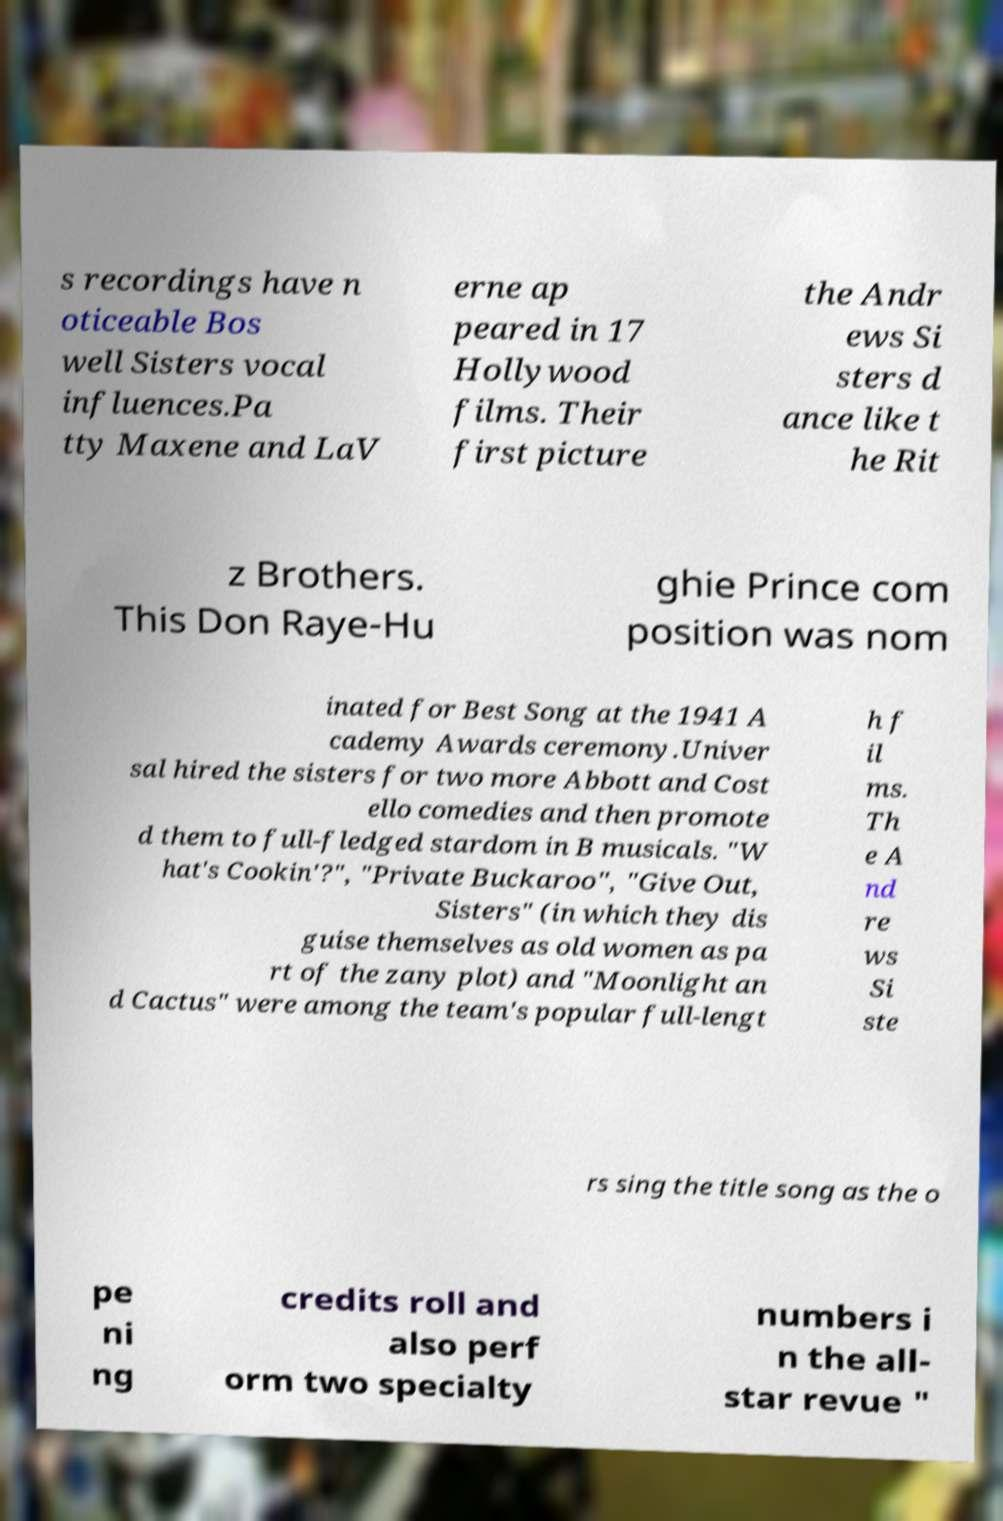Can you read and provide the text displayed in the image?This photo seems to have some interesting text. Can you extract and type it out for me? s recordings have n oticeable Bos well Sisters vocal influences.Pa tty Maxene and LaV erne ap peared in 17 Hollywood films. Their first picture the Andr ews Si sters d ance like t he Rit z Brothers. This Don Raye-Hu ghie Prince com position was nom inated for Best Song at the 1941 A cademy Awards ceremony.Univer sal hired the sisters for two more Abbott and Cost ello comedies and then promote d them to full-fledged stardom in B musicals. "W hat's Cookin'?", "Private Buckaroo", "Give Out, Sisters" (in which they dis guise themselves as old women as pa rt of the zany plot) and "Moonlight an d Cactus" were among the team's popular full-lengt h f il ms. Th e A nd re ws Si ste rs sing the title song as the o pe ni ng credits roll and also perf orm two specialty numbers i n the all- star revue " 